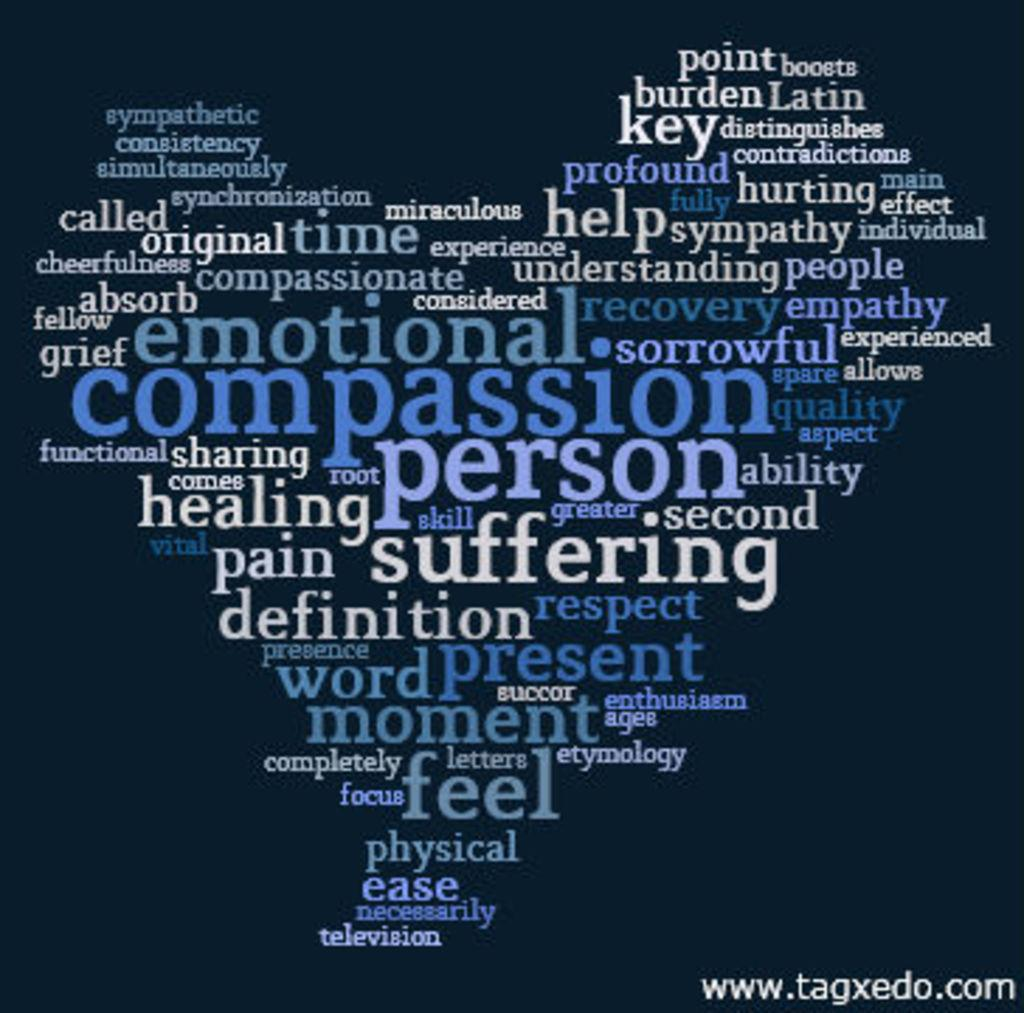<image>
Share a concise interpretation of the image provided. An inspirational poster written in varying shades of blue letters put out by www.tagxedo.com. 